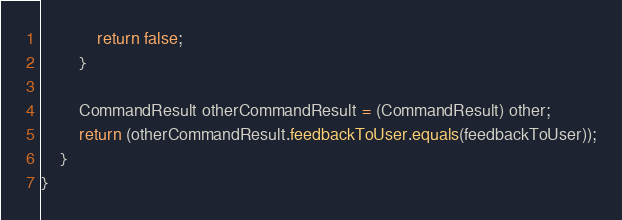Convert code to text. <code><loc_0><loc_0><loc_500><loc_500><_Java_>            return false;
        }

        CommandResult otherCommandResult = (CommandResult) other;
        return (otherCommandResult.feedbackToUser.equals(feedbackToUser));
    }
}
</code> 